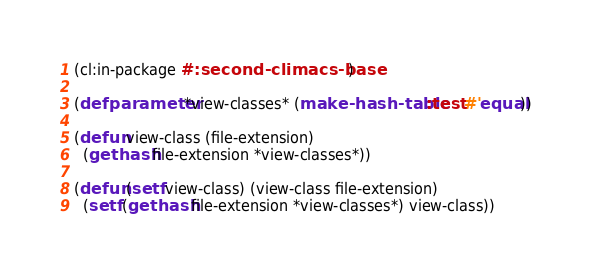<code> <loc_0><loc_0><loc_500><loc_500><_Lisp_>(cl:in-package #:second-climacs-base)

(defparameter *view-classes* (make-hash-table :test #'equal))

(defun view-class (file-extension)
  (gethash file-extension *view-classes*))

(defun (setf view-class) (view-class file-extension)
  (setf (gethash file-extension *view-classes*) view-class))
</code> 